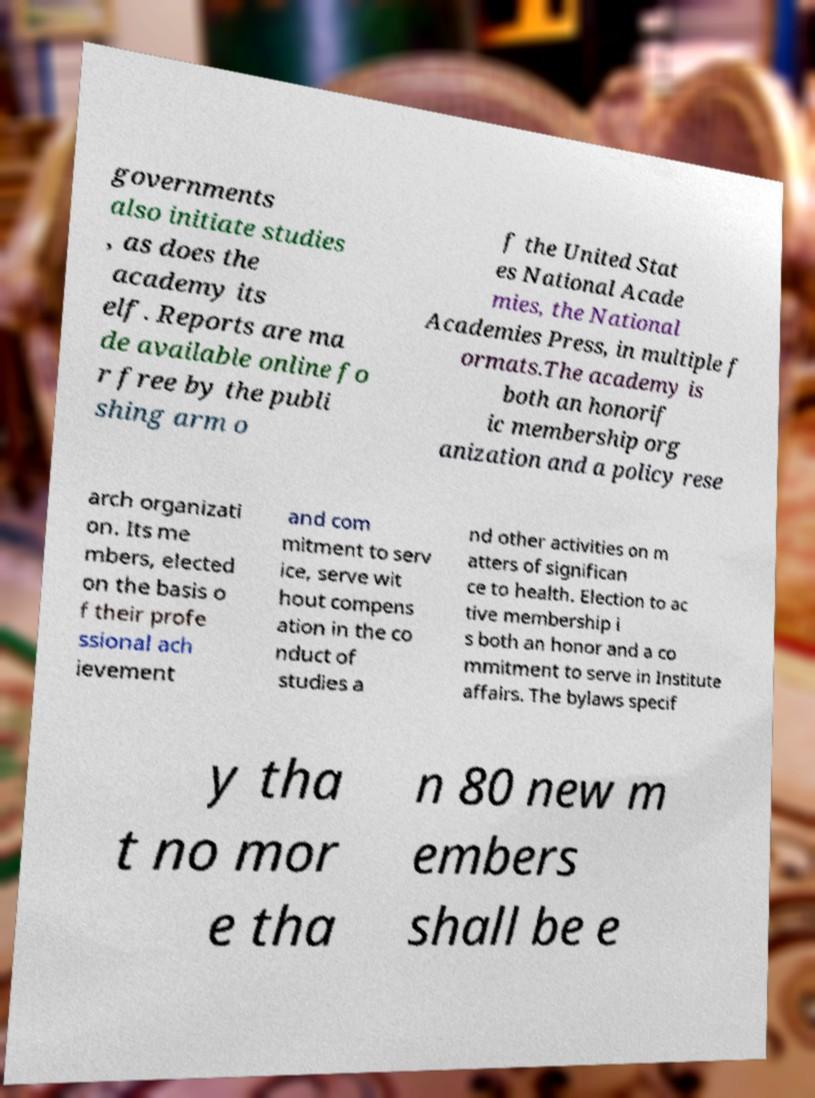Could you assist in decoding the text presented in this image and type it out clearly? governments also initiate studies , as does the academy its elf. Reports are ma de available online fo r free by the publi shing arm o f the United Stat es National Acade mies, the National Academies Press, in multiple f ormats.The academy is both an honorif ic membership org anization and a policy rese arch organizati on. Its me mbers, elected on the basis o f their profe ssional ach ievement and com mitment to serv ice, serve wit hout compens ation in the co nduct of studies a nd other activities on m atters of significan ce to health. Election to ac tive membership i s both an honor and a co mmitment to serve in Institute affairs. The bylaws specif y tha t no mor e tha n 80 new m embers shall be e 